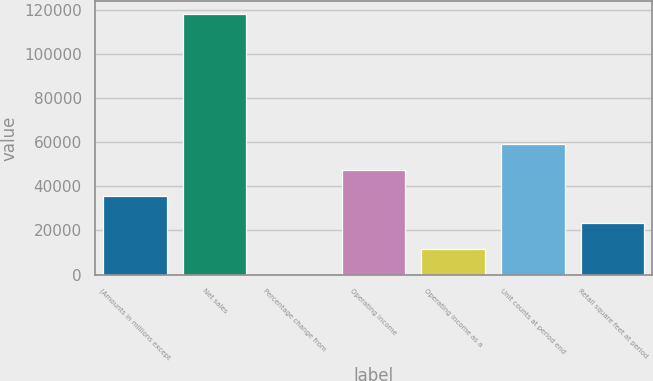<chart> <loc_0><loc_0><loc_500><loc_500><bar_chart><fcel>(Amounts in millions except<fcel>Net sales<fcel>Percentage change from<fcel>Operating income<fcel>Operating income as a<fcel>Unit counts at period end<fcel>Retail square feet at period<nl><fcel>35421.6<fcel>118068<fcel>1.7<fcel>47228.2<fcel>11808.3<fcel>59034.8<fcel>23615<nl></chart> 